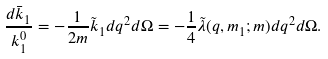Convert formula to latex. <formula><loc_0><loc_0><loc_500><loc_500>\frac { d \bar { k } _ { 1 } } { k ^ { 0 } _ { 1 } } = - \frac { 1 } { 2 m } \tilde { k } _ { 1 } d q ^ { 2 } d \Omega = - \frac { 1 } { 4 } \tilde { \lambda } ( q , m _ { 1 } ; m ) d q ^ { 2 } d \Omega .</formula> 